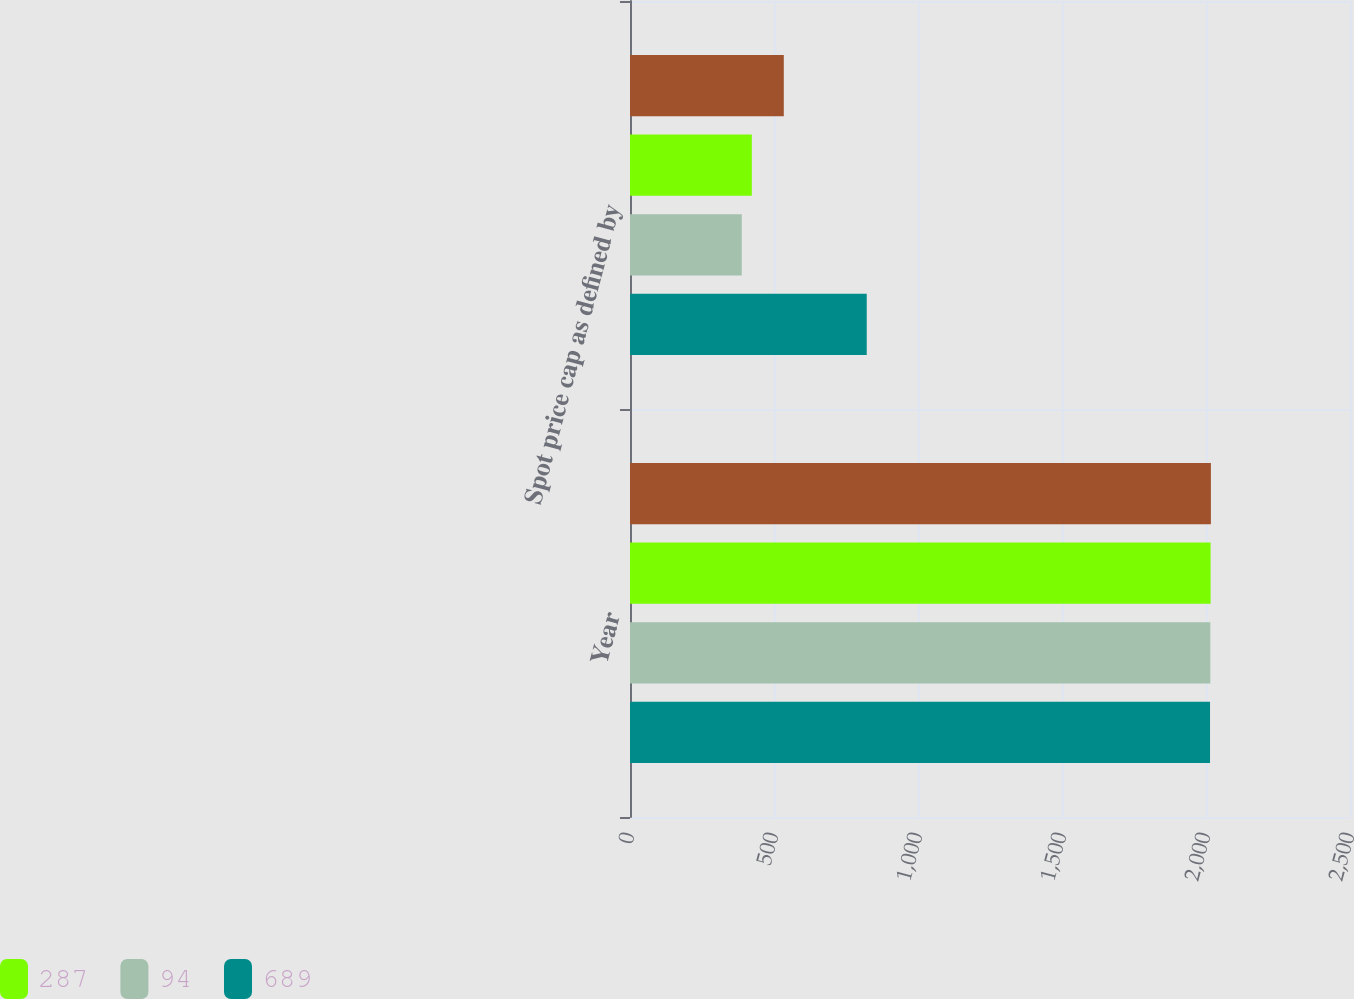<chart> <loc_0><loc_0><loc_500><loc_500><stacked_bar_chart><ecel><fcel>Year<fcel>Spot price cap as defined by<nl><fcel>nan<fcel>2017<fcel>534<nl><fcel>287<fcel>2016<fcel>423<nl><fcel>94<fcel>2015<fcel>388<nl><fcel>689<fcel>2014<fcel>822<nl></chart> 